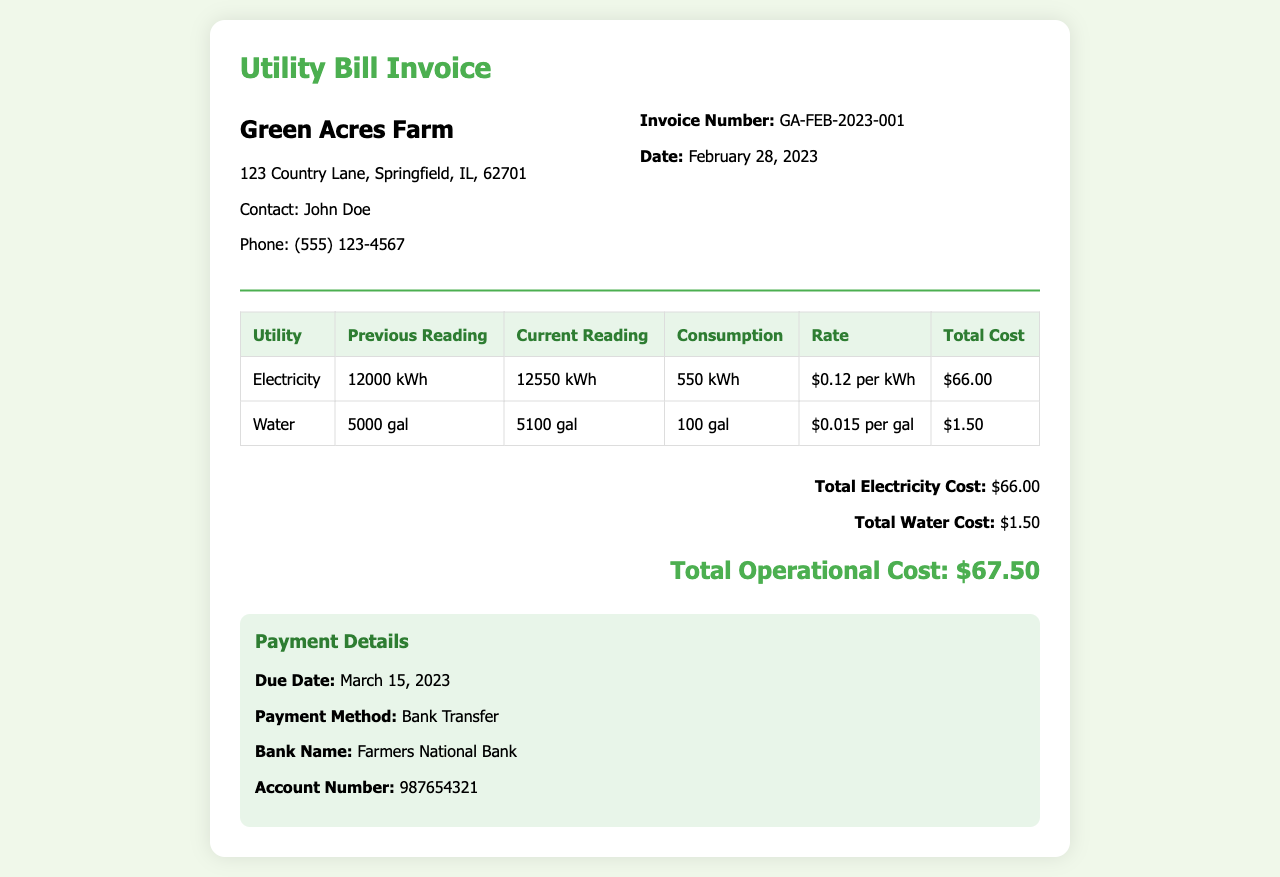What is the invoice number? The invoice number is specifically mentioned in the document, which is GA-FEB-2023-001.
Answer: GA-FEB-2023-001 What is the due date for this invoice? The due date for payment is clearly stated in the document, which is March 15, 2023.
Answer: March 15, 2023 How much was the total cost for electricity? The total cost for electricity is provided in the charges summary and amounts to $66.00.
Answer: $66.00 What is the rate for water consumption? The rate for water consumption is indicated in the table, which is $0.015 per gallon.
Answer: $0.015 per gal What utility had the highest consumption in February 2023? By comparing the consumption figures, the utility with the highest consumption is electricity, with 550 kWh used.
Answer: Electricity What is the total operational cost? The total operational cost is derived from summing the costs of all utilities, which equals $67.50.
Answer: $67.50 Who should be contacted for inquiries regarding this invoice? The contact person for inquiries listed in the document is John Doe.
Answer: John Doe What is the payment method specified in the document? The payment method is defined in the payment details, which is Bank Transfer.
Answer: Bank Transfer How many gallons of water were consumed? The document lists the final water consumption figure as 100 gallons.
Answer: 100 gal 